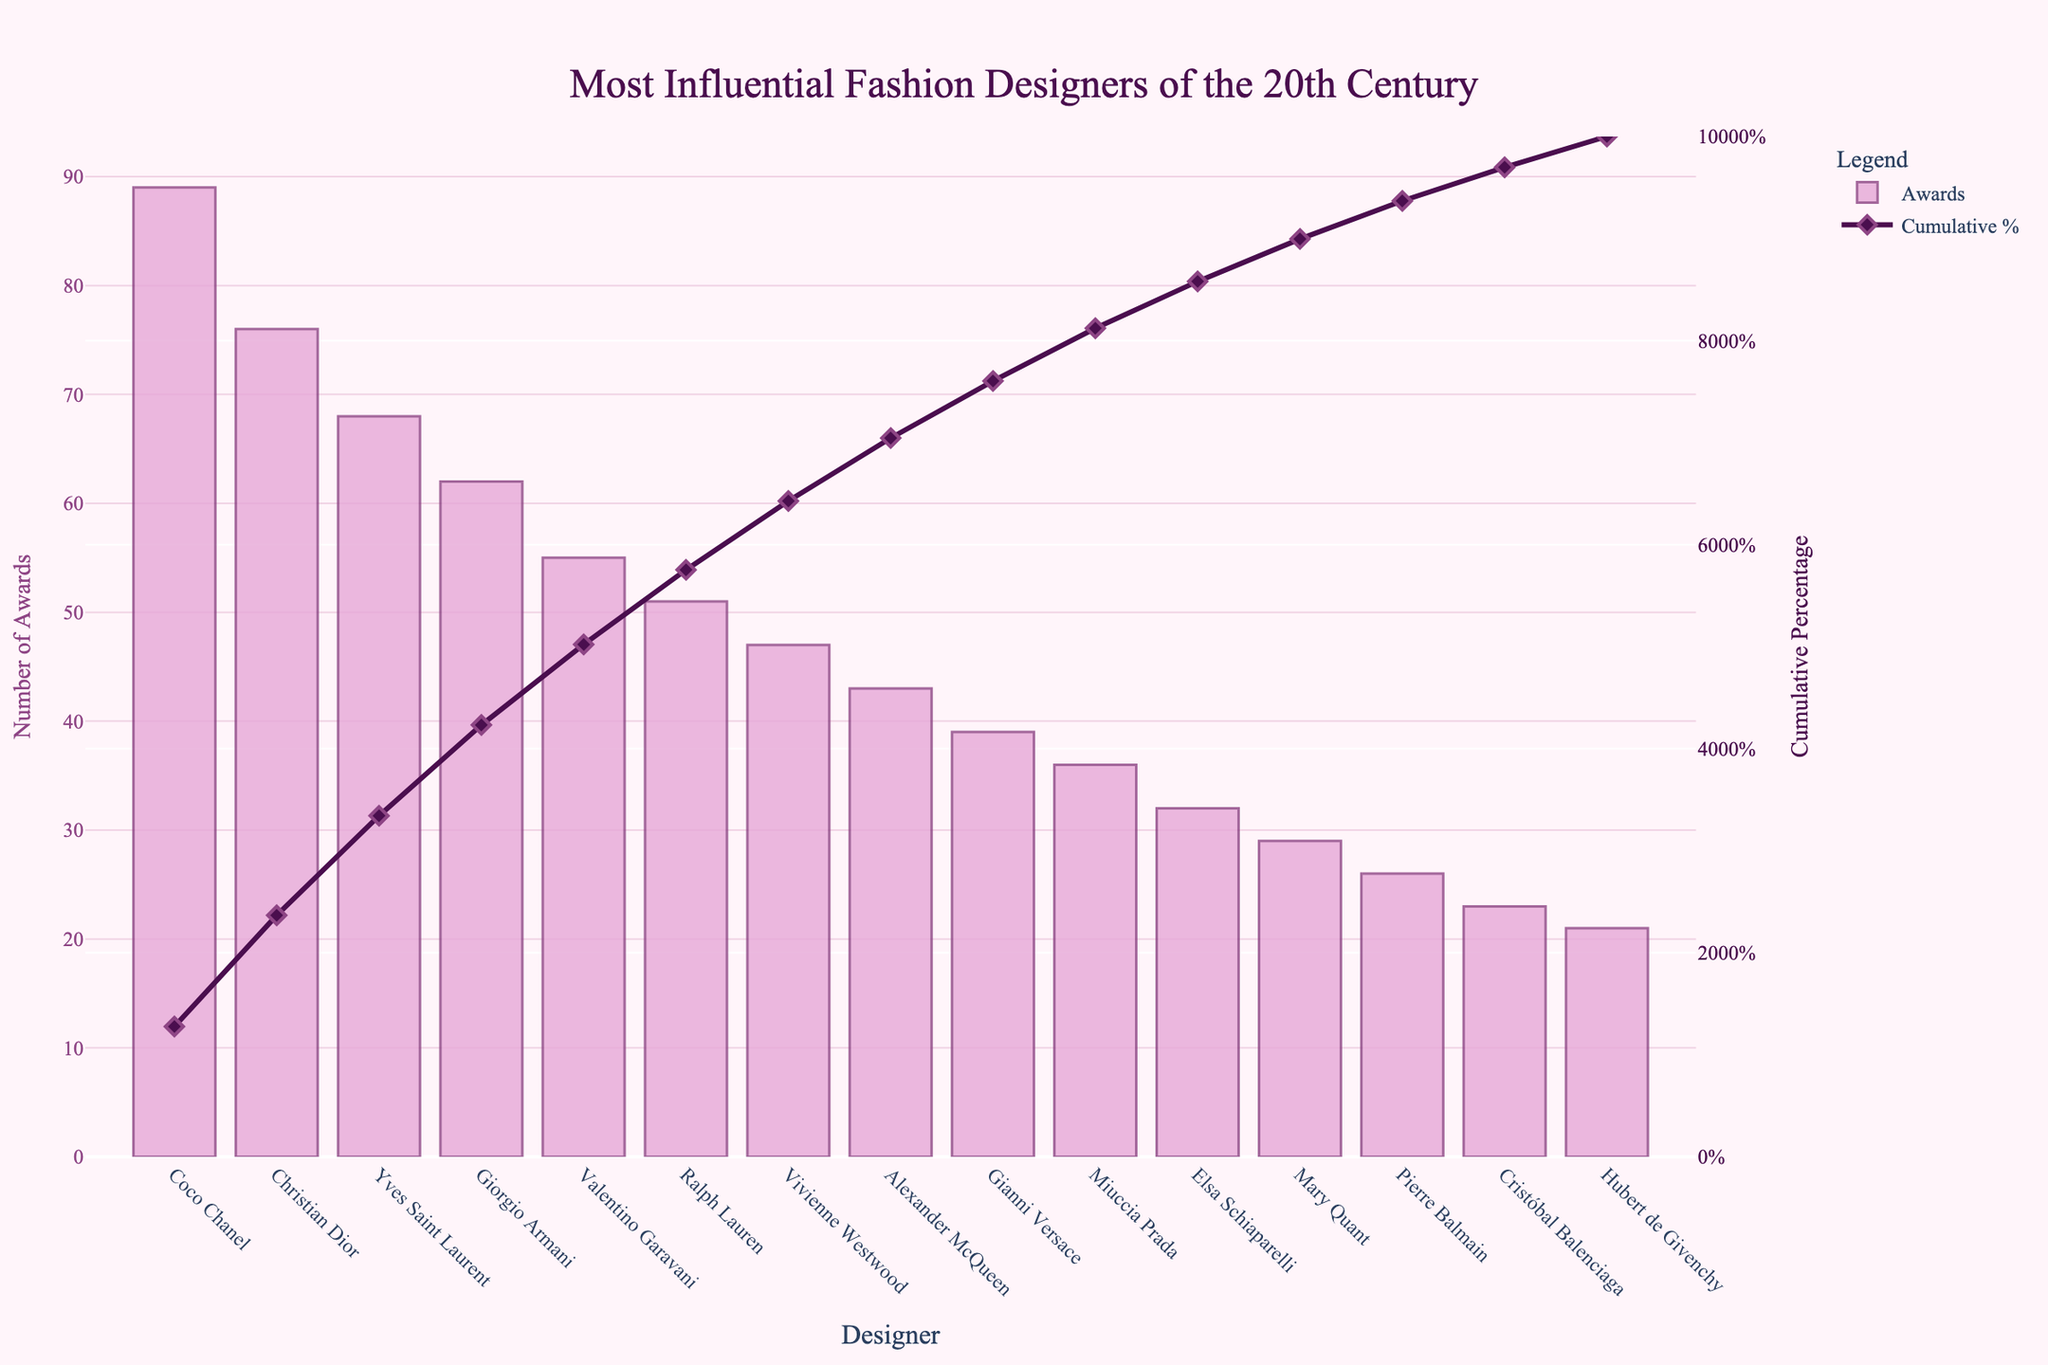Who is the most influential fashion designer according to the number of industry awards? The chart shows a bar where the designer with the highest number of awards is represented. From the bar chart, we see that Coco Chanel has the highest bar, indicating she has the most awards.
Answer: Coco Chanel Who are the top three designers based on the number of awards received? By looking at the three highest bars in the chart, we can identify the top three designers. These are Coco Chanel, Christian Dior, and Yves Saint Laurent in descending order of awards.
Answer: Coco Chanel, Christian Dior, Yves Saint Laurent What is the cumulative percentage of the top two designers? The cumulative percentage line shows the cumulative awards percentage of designers from left to right. For the top two designers (Coco Chanel and Christian Dior), the values are added from the chart. Coco Chanel's cumulative percentage is the value at her bar, and Christian Dior's cumulative percentage is just after Dior. Adding these gives us Coco Chanel's 19.67% plus Christian Dior's 36.57%.
Answer: 36.57% Which designer is ranked seventh by the number of awards? The seventh highest bar corresponds to the designer with the seventh most awards. Counting the bars from left to right, we identify that Vivienne Westwood is the seventh designer.
Answer: Vivienne Westwood By what percentage has Giorgio Armani contributed to the cumulative percentage? To find Giorgio Armani's contribution, we locate his position on the bar chart and look at the cumulative percentage line at his mark, which represents the total percentage up to his point. Giorgio Armani's cumulative percentage is the percentage noted after his bar on the chart.
Answer: 54.92% How many awards separate Ralph Lauren from Alexander McQueen? By looking at the length of the bars corresponding to Ralph Lauren and Alexander McQueen, we subtract the number of awards Alexander McQueen has from Ralph Lauren's awards. Ralph Lauren has 51 awards while Alexander McQueen has 43. 51 - 43 gives the difference.
Answer: 8 What percentage of the total awards does the cumulative line reach after the top five designers? Following the cumulative percentage line up to the fifth designer, Valentino Garavani, we note the percentage at this point on the chart. The cumulative line reaches 62.60% at Valentino Garavani.
Answer: 62.60% Who has more awards, Mary Quant or Elsa Schiaparelli? By comparing the heights of the bars for Mary Quant and Elsa Schiaparelli, we can see which one is taller, indicating more awards. Elsa Schiaparelli's bar is higher, indicating she has more awards.
Answer: Elsa Schiaparelli What is the total number of awards received by the top five designers combined? The top five designers are Coco Chanel, Christian Dior, Yves Saint Laurent, Giorgio Armani, and Valentino Garavani. Summing their awards gives us 89 + 76 + 68 + 62 + 55. The calculation is 350.
Answer: 350 What cumulative percentage do Alexander McQueen and Gianni Versace collectively contribute? First, look at the cumulative percentage after Alexander McQueen which is 82.51%. Then subtract the cumulative percentage right before Alexander McQueen, which is after Ralph Lauren 76.91%. The difference represents Alexander McQueen's and Gianni Versace's combined contribution 82.51% - 76.91% = 5.6%.
Answer: 5.6% 